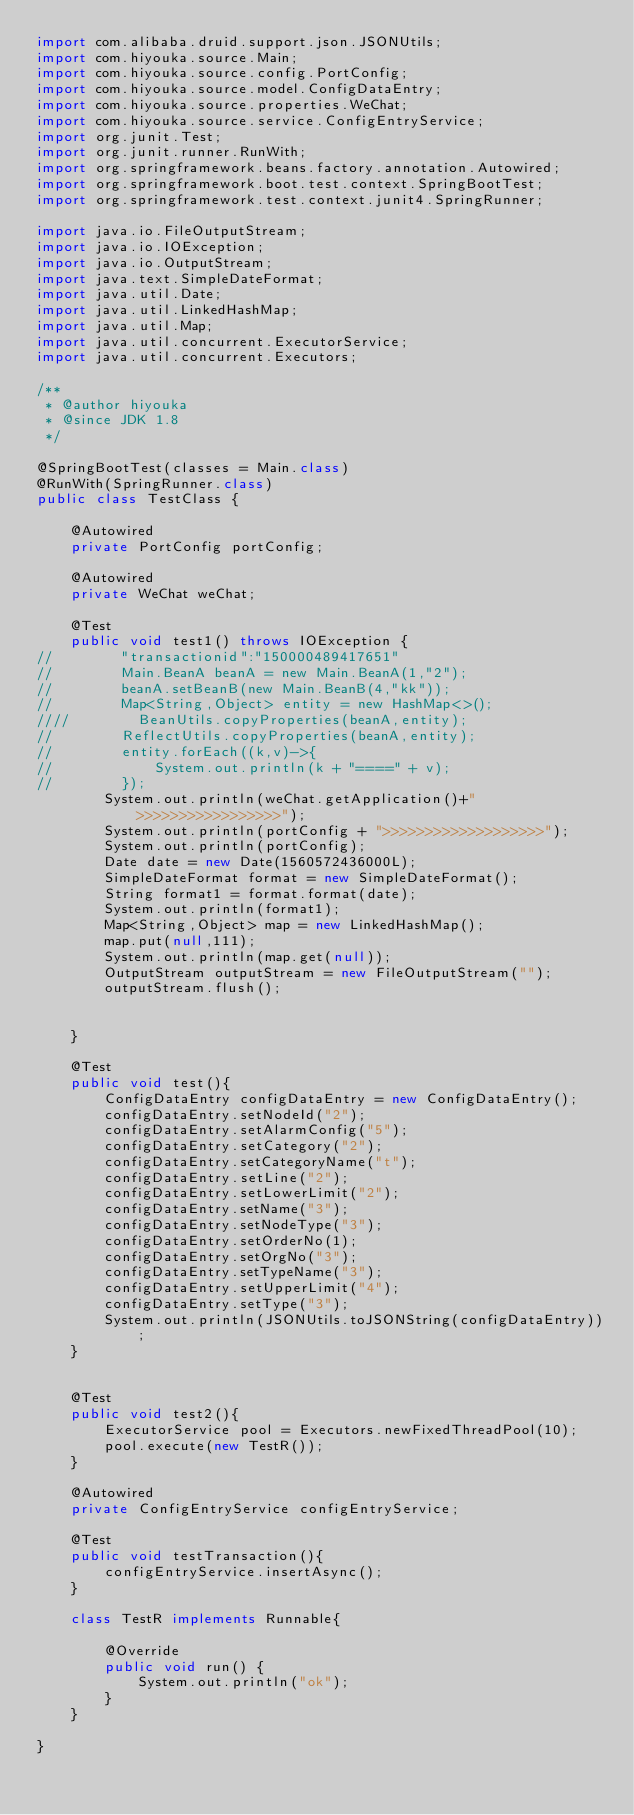Convert code to text. <code><loc_0><loc_0><loc_500><loc_500><_Java_>import com.alibaba.druid.support.json.JSONUtils;
import com.hiyouka.source.Main;
import com.hiyouka.source.config.PortConfig;
import com.hiyouka.source.model.ConfigDataEntry;
import com.hiyouka.source.properties.WeChat;
import com.hiyouka.source.service.ConfigEntryService;
import org.junit.Test;
import org.junit.runner.RunWith;
import org.springframework.beans.factory.annotation.Autowired;
import org.springframework.boot.test.context.SpringBootTest;
import org.springframework.test.context.junit4.SpringRunner;

import java.io.FileOutputStream;
import java.io.IOException;
import java.io.OutputStream;
import java.text.SimpleDateFormat;
import java.util.Date;
import java.util.LinkedHashMap;
import java.util.Map;
import java.util.concurrent.ExecutorService;
import java.util.concurrent.Executors;

/**
 * @author hiyouka
 * @since JDK 1.8
 */

@SpringBootTest(classes = Main.class)
@RunWith(SpringRunner.class)
public class TestClass {

    @Autowired
    private PortConfig portConfig;

    @Autowired
    private WeChat weChat;

    @Test
    public void test1() throws IOException {
//        "transactionid":"150000489417651"
//        Main.BeanA beanA = new Main.BeanA(1,"2");
//        beanA.setBeanB(new Main.BeanB(4,"kk"));
//        Map<String,Object> entity = new HashMap<>();
////        BeanUtils.copyProperties(beanA,entity);
//        ReflectUtils.copyProperties(beanA,entity);
//        entity.forEach((k,v)->{
//            System.out.println(k + "====" + v);
//        });
        System.out.println(weChat.getApplication()+">>>>>>>>>>>>>>>>>");
        System.out.println(portConfig + ">>>>>>>>>>>>>>>>>>>");
        System.out.println(portConfig);
        Date date = new Date(1560572436000L);
        SimpleDateFormat format = new SimpleDateFormat();
        String format1 = format.format(date);
        System.out.println(format1);
        Map<String,Object> map = new LinkedHashMap();
        map.put(null,111);
        System.out.println(map.get(null));
        OutputStream outputStream = new FileOutputStream("");
        outputStream.flush();


    }

    @Test
    public void test(){
        ConfigDataEntry configDataEntry = new ConfigDataEntry();
        configDataEntry.setNodeId("2");
        configDataEntry.setAlarmConfig("5");
        configDataEntry.setCategory("2");
        configDataEntry.setCategoryName("t");
        configDataEntry.setLine("2");
        configDataEntry.setLowerLimit("2");
        configDataEntry.setName("3");
        configDataEntry.setNodeType("3");
        configDataEntry.setOrderNo(1);
        configDataEntry.setOrgNo("3");
        configDataEntry.setTypeName("3");
        configDataEntry.setUpperLimit("4");
        configDataEntry.setType("3");
        System.out.println(JSONUtils.toJSONString(configDataEntry));
    }


    @Test
    public void test2(){
        ExecutorService pool = Executors.newFixedThreadPool(10);
        pool.execute(new TestR());
    }

    @Autowired
    private ConfigEntryService configEntryService;

    @Test
    public void testTransaction(){
        configEntryService.insertAsync();
    }

    class TestR implements Runnable{

        @Override
        public void run() {
            System.out.println("ok");
        }
    }

}</code> 